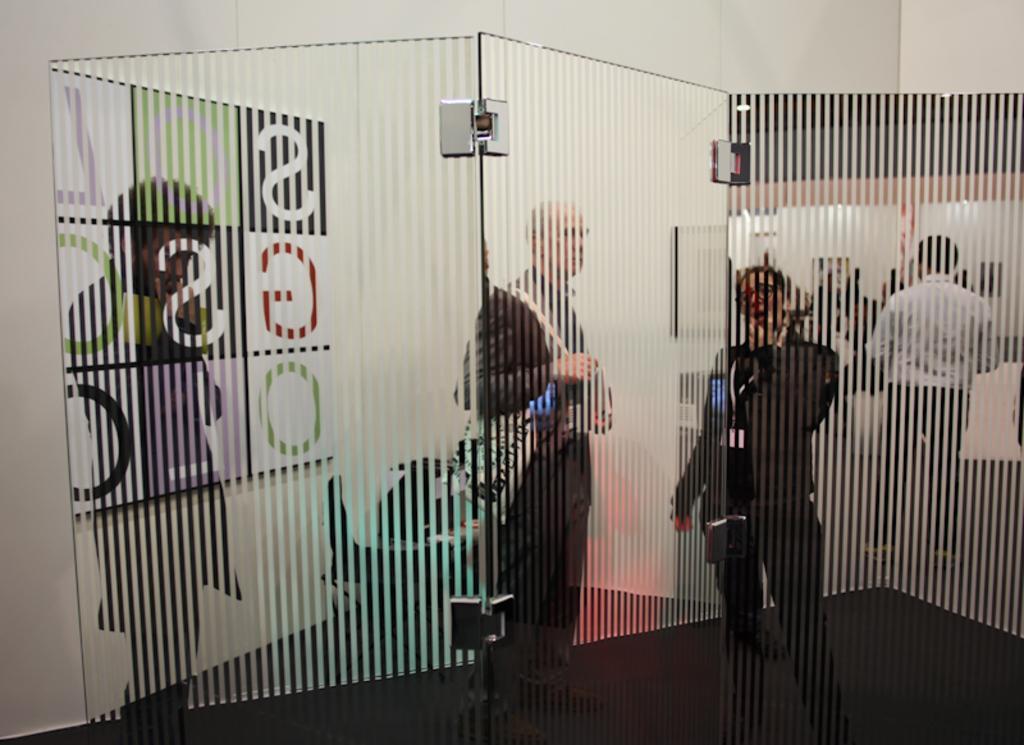How would you summarize this image in a sentence or two? In this image in the front there is glass. In the background there are persons standing and there is a wall which is white in colour. 